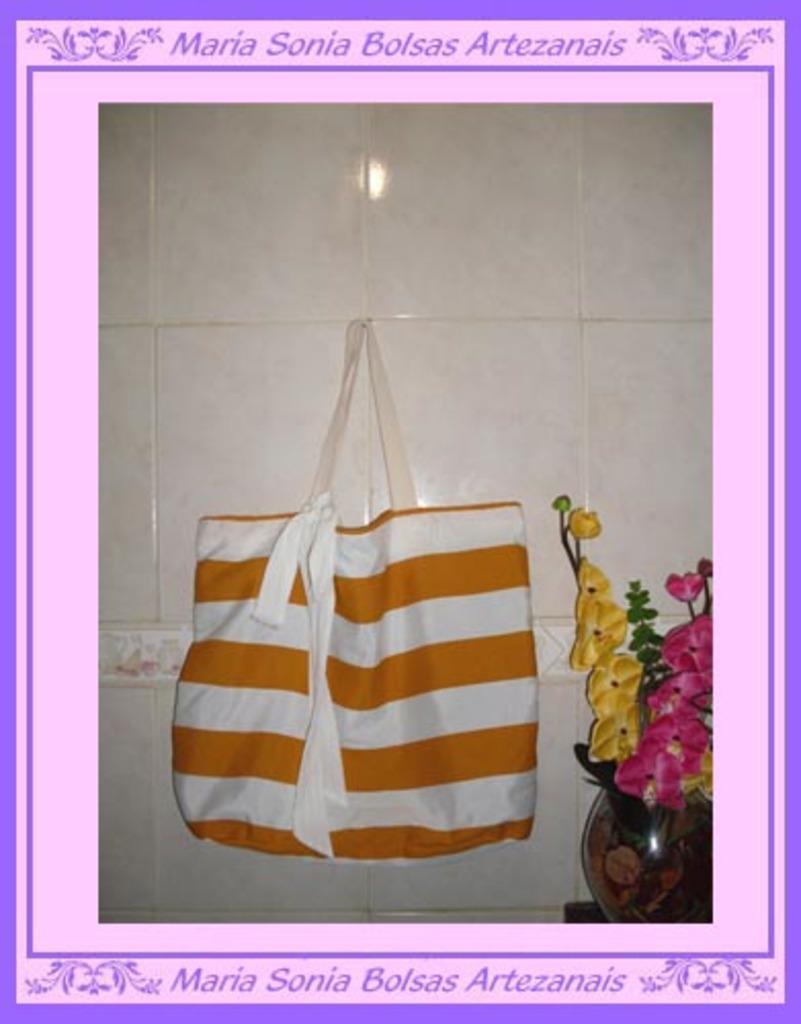Could you give a brief overview of what you see in this image? In the image there is a bag hanging on to the wall and beside that there is a flower vase and the image is edited on a computer. 